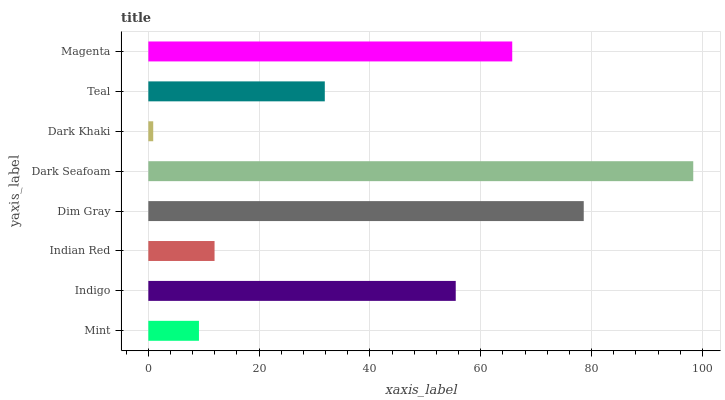Is Dark Khaki the minimum?
Answer yes or no. Yes. Is Dark Seafoam the maximum?
Answer yes or no. Yes. Is Indigo the minimum?
Answer yes or no. No. Is Indigo the maximum?
Answer yes or no. No. Is Indigo greater than Mint?
Answer yes or no. Yes. Is Mint less than Indigo?
Answer yes or no. Yes. Is Mint greater than Indigo?
Answer yes or no. No. Is Indigo less than Mint?
Answer yes or no. No. Is Indigo the high median?
Answer yes or no. Yes. Is Teal the low median?
Answer yes or no. Yes. Is Teal the high median?
Answer yes or no. No. Is Dark Seafoam the low median?
Answer yes or no. No. 